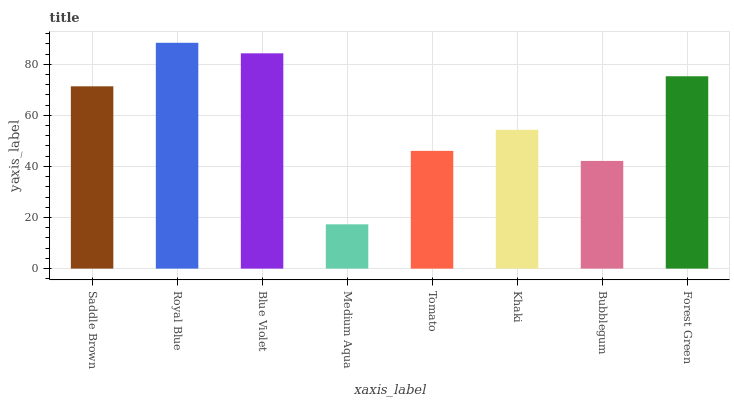Is Medium Aqua the minimum?
Answer yes or no. Yes. Is Royal Blue the maximum?
Answer yes or no. Yes. Is Blue Violet the minimum?
Answer yes or no. No. Is Blue Violet the maximum?
Answer yes or no. No. Is Royal Blue greater than Blue Violet?
Answer yes or no. Yes. Is Blue Violet less than Royal Blue?
Answer yes or no. Yes. Is Blue Violet greater than Royal Blue?
Answer yes or no. No. Is Royal Blue less than Blue Violet?
Answer yes or no. No. Is Saddle Brown the high median?
Answer yes or no. Yes. Is Khaki the low median?
Answer yes or no. Yes. Is Khaki the high median?
Answer yes or no. No. Is Tomato the low median?
Answer yes or no. No. 